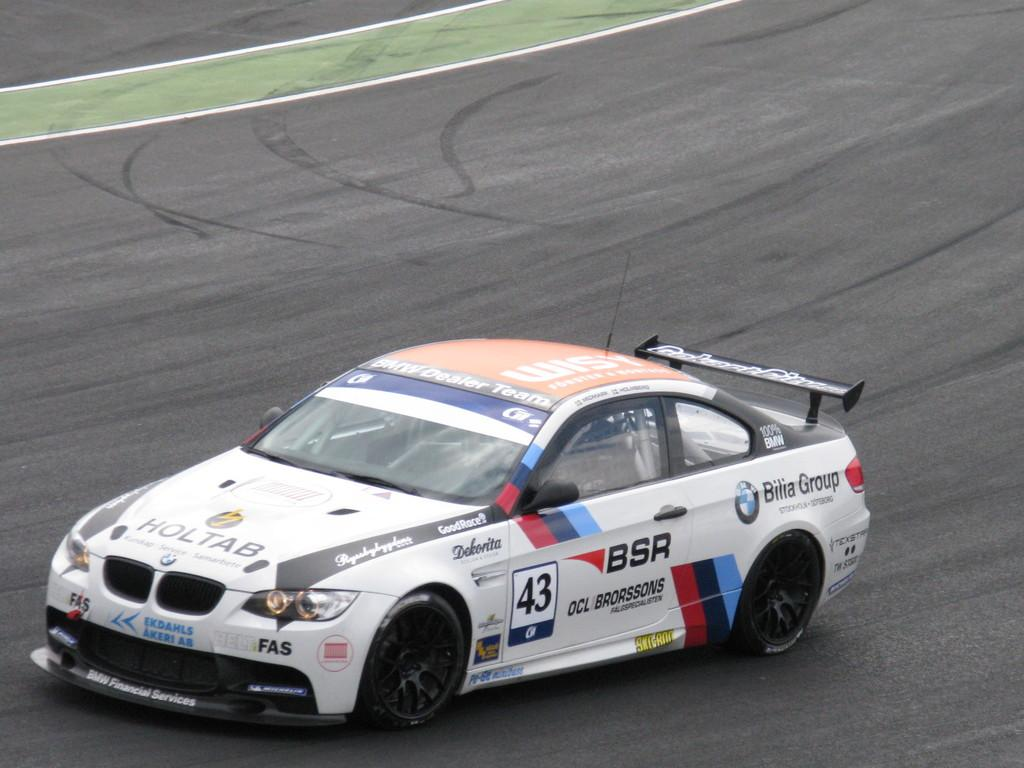What is the main subject of the image? The main subject of the image is a car. Where is the car located in the image? The car is on the road in the image. What color is the car? The car is white in color. Are there any markings or text on the car? Yes, there is text on the car. What type of trousers is the car wearing in the image? Cars do not wear trousers; the question is not applicable to the image. 